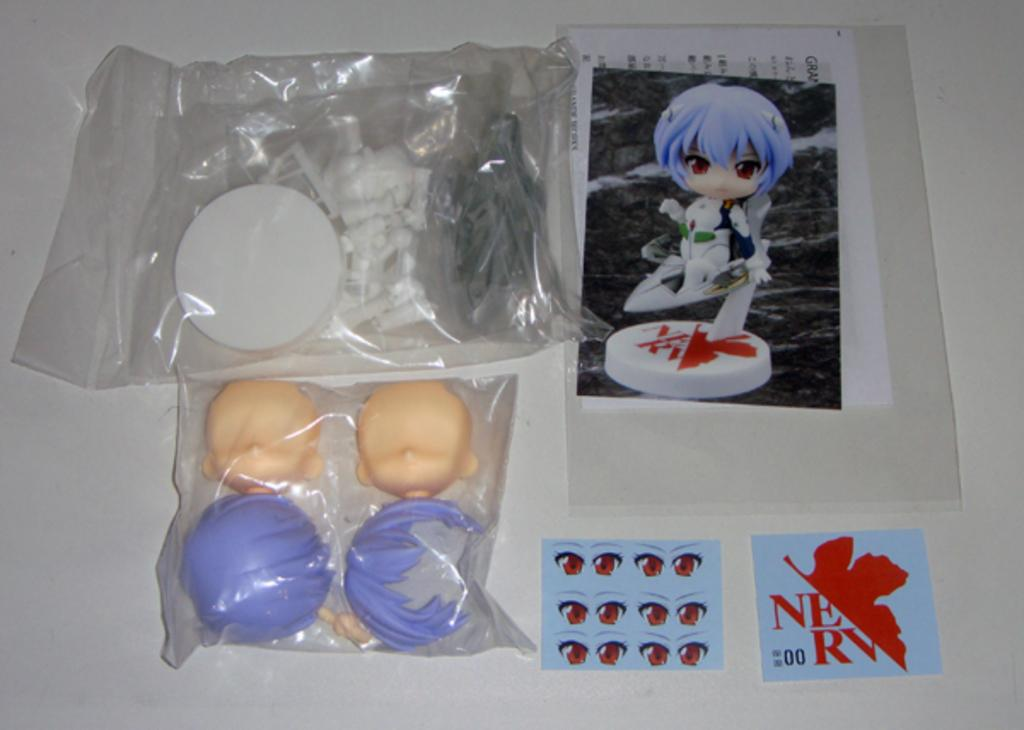What types of objects are present in the image? There are objects and toy objects in the image. How are the objects and toy objects arranged in the image? The objects and toy objects are placed in separate covers. What else can be seen in the image besides the objects and toy objects? There is a photograph on paper and two cards on a platform in the image. Can you tell me how many monkeys are sitting on the cards in the image? There are no monkeys present in the image; it features objects, toy objects, a photograph on paper, and two cards on a platform. What color is the nose of the monkey in the image? There is no monkey present in the image, so it is not possible to determine the color of its nose. 